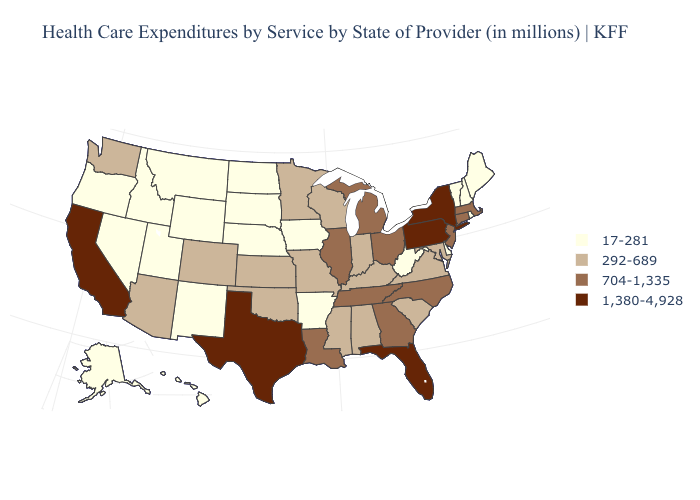Does Oregon have the lowest value in the West?
Write a very short answer. Yes. Name the states that have a value in the range 704-1,335?
Answer briefly. Connecticut, Georgia, Illinois, Louisiana, Massachusetts, Michigan, New Jersey, North Carolina, Ohio, Tennessee. Does Washington have the same value as Wyoming?
Give a very brief answer. No. What is the lowest value in the USA?
Quick response, please. 17-281. What is the value of Wyoming?
Answer briefly. 17-281. Does Texas have the highest value in the USA?
Concise answer only. Yes. Among the states that border Tennessee , which have the highest value?
Be succinct. Georgia, North Carolina. What is the highest value in states that border West Virginia?
Keep it brief. 1,380-4,928. Does the first symbol in the legend represent the smallest category?
Be succinct. Yes. What is the lowest value in the USA?
Answer briefly. 17-281. What is the value of Hawaii?
Answer briefly. 17-281. Does Nebraska have the highest value in the USA?
Answer briefly. No. Does the first symbol in the legend represent the smallest category?
Write a very short answer. Yes. Does the first symbol in the legend represent the smallest category?
Be succinct. Yes. Is the legend a continuous bar?
Short answer required. No. 